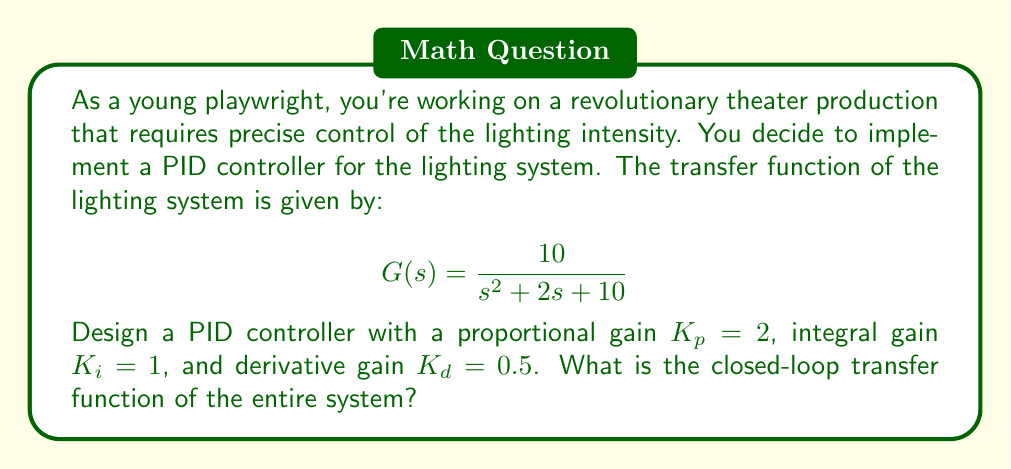Show me your answer to this math problem. To solve this problem, we'll follow these steps:

1. Write the transfer function of the PID controller.
2. Combine the controller and plant transfer functions to get the open-loop transfer function.
3. Use the closed-loop formula to determine the final transfer function.

Step 1: PID Controller Transfer Function

The transfer function of a PID controller is given by:

$$C(s) = K_p + \frac{K_i}{s} + K_d s$$

Substituting the given values:

$$C(s) = 2 + \frac{1}{s} + 0.5s = \frac{2s^2 + s + 1}{s}$$

Step 2: Open-Loop Transfer Function

The open-loop transfer function is the product of the controller and plant transfer functions:

$$G_{OL}(s) = C(s) \cdot G(s) = \frac{2s^2 + s + 1}{s} \cdot \frac{10}{s^2 + 2s + 10}$$

$$G_{OL}(s) = \frac{10(2s^2 + s + 1)}{s(s^2 + 2s + 10)}$$

Step 3: Closed-Loop Transfer Function

The closed-loop transfer function is given by:

$$G_{CL}(s) = \frac{G_{OL}(s)}{1 + G_{OL}(s)}$$

Substituting the open-loop transfer function:

$$G_{CL}(s) = \frac{\frac{10(2s^2 + s + 1)}{s(s^2 + 2s + 10)}}{1 + \frac{10(2s^2 + s + 1)}{s(s^2 + 2s + 10)}}$$

Simplifying:

$$G_{CL}(s) = \frac{10(2s^2 + s + 1)}{s(s^2 + 2s + 10) + 10(2s^2 + s + 1)}$$

$$G_{CL}(s) = \frac{10(2s^2 + s + 1)}{s^3 + 2s^2 + 10s + 20s^2 + 10s + 10}$$

$$G_{CL}(s) = \frac{20s^2 + 10s + 10}{s^3 + 22s^2 + 20s + 10}$$
Answer: $$G_{CL}(s) = \frac{20s^2 + 10s + 10}{s^3 + 22s^2 + 20s + 10}$$ 